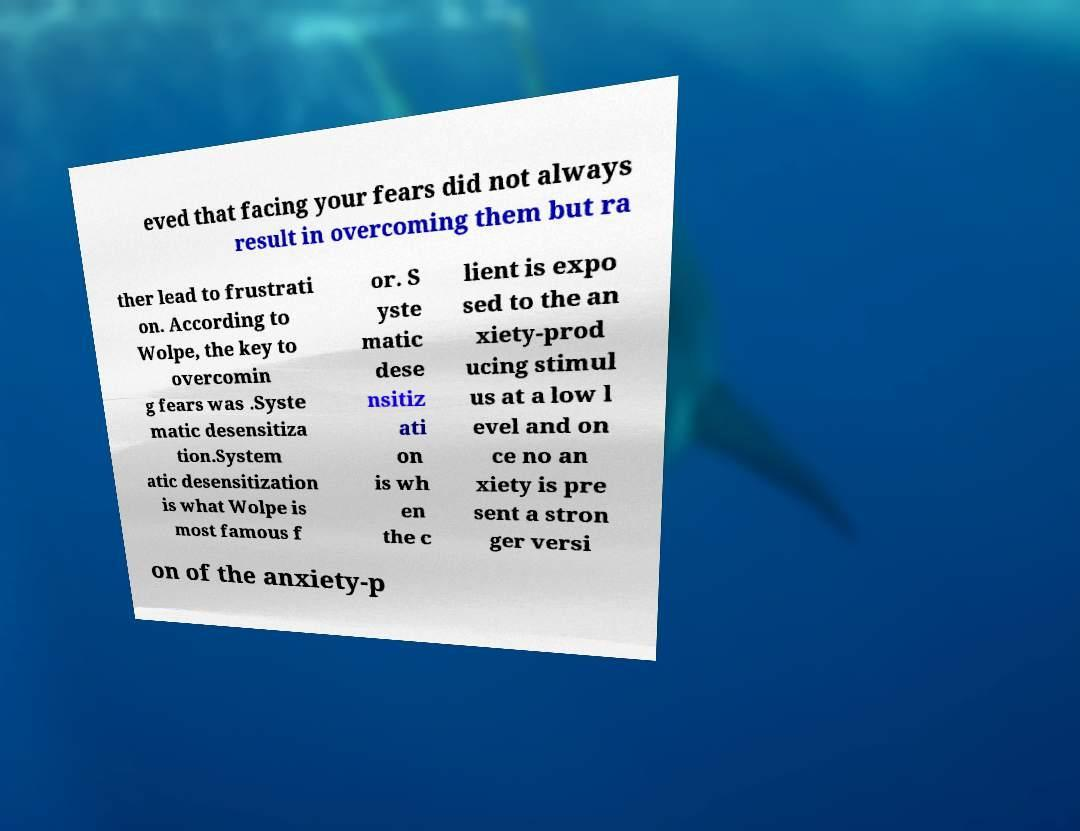Could you extract and type out the text from this image? eved that facing your fears did not always result in overcoming them but ra ther lead to frustrati on. According to Wolpe, the key to overcomin g fears was .Syste matic desensitiza tion.System atic desensitization is what Wolpe is most famous f or. S yste matic dese nsitiz ati on is wh en the c lient is expo sed to the an xiety-prod ucing stimul us at a low l evel and on ce no an xiety is pre sent a stron ger versi on of the anxiety-p 